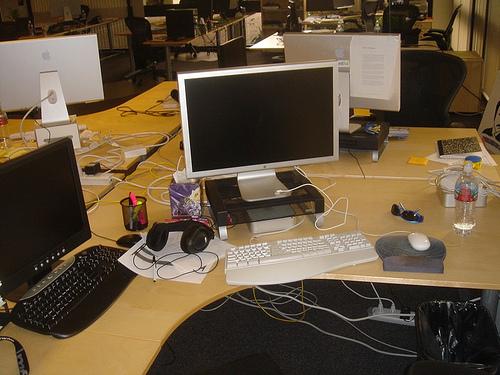Why are the pink and yellow markers bright neon colors?
Concise answer only. Highlighters. What is in the plastic bottle?
Be succinct. Water. What is in the purple box behind the monitor?
Write a very short answer. Tissues. 